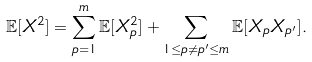Convert formula to latex. <formula><loc_0><loc_0><loc_500><loc_500>\mathbb { E } [ X ^ { 2 } ] = \sum _ { p = 1 } ^ { m } \mathbb { E } [ X _ { p } ^ { 2 } ] + \sum _ { 1 \leq p \neq p ^ { \prime } \leq m } \mathbb { E } [ X _ { p } X _ { p ^ { \prime } } ] .</formula> 